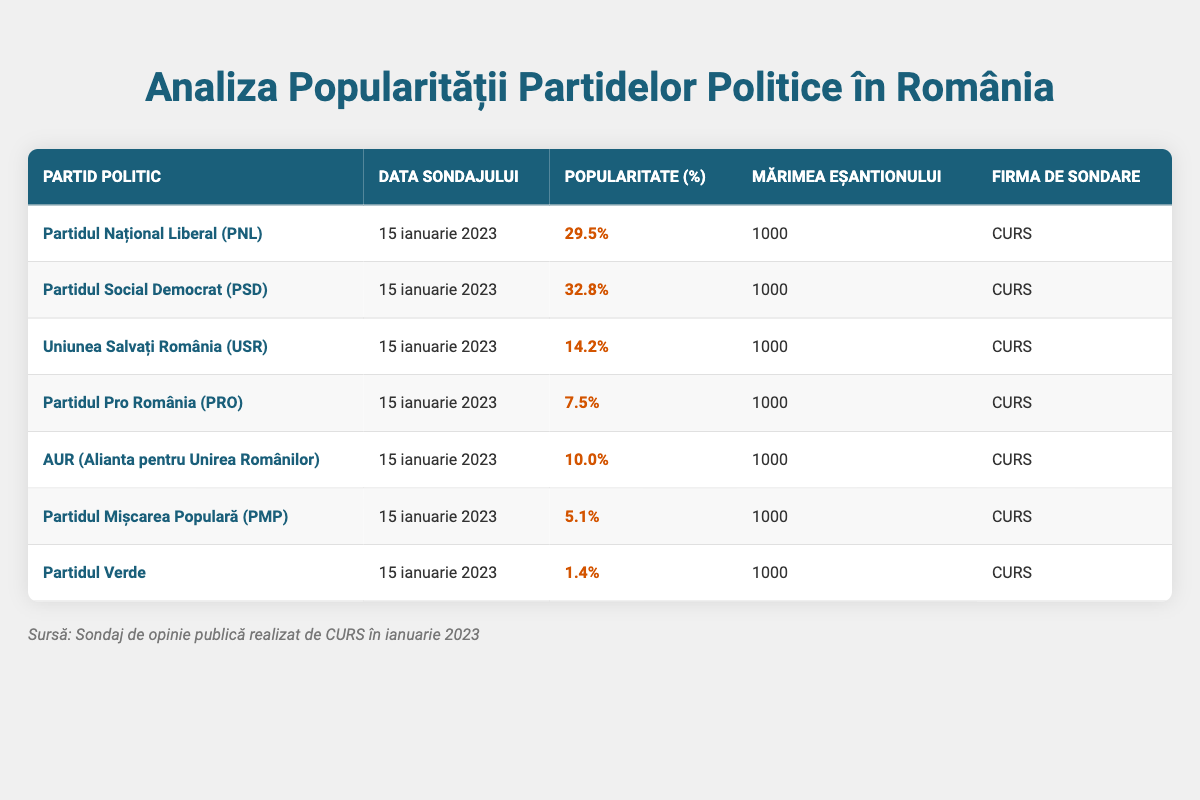What is the popularity percentage of Partidul Național Liberal (PNL)? The table shows that the popularity percentage of Partidul Național Liberal (PNL) is listed directly in the corresponding row under the "Popularitate (%)" column. According to the data, it is 29.5%.
Answer: 29.5% Which party has the highest popularity percentage? By reviewing the "Popularitate (%)" column, we see that Partidul Social Democrat (PSD) has the highest percentage at 32.8%. This value is greater than any other listed party in the table.
Answer: Partidul Social Democrat (PSD) How many parties have a popularity percentage below 10%? We need to look at the "Popularitate (%)" column and count how many entries are below 10%. Partidul Pro România (PRO) at 7.5%, AUR at 10.0%, Partidul Mișcarea Populară (PMP) at 5.1%, and Partidul Verde at 1.4% indicate that three parties (PRO, PMP, and Verde) have a popularity percentage below 10%.
Answer: 3 What is the average popularity percentage of all the political parties listed? To calculate the average, we sum the popularity percentages: 29.5 + 32.8 + 14.2 + 7.5 + 10.0 + 5.1 + 1.4 = 100.5. There are 7 parties, so the average is 100.5 / 7 = 14.36%.
Answer: 14.36% Is the sample size the same for all parties? Checking the "Mărimea Eșantionului" column, we observe that all entries show a sample size of 1000, confirming that the sample size is consistent for all parties in this survey.
Answer: Yes Which party has the lowest popularity percentage? Inspecting the "Popularitate (%)" column, we can see that Partidul Verde has the lowest percentage at 1.4%. This is visibly lower than all other values in the column.
Answer: Partidul Verde What percentage difference in popularity is there between Partidul Social Democrat (PSD) and Uniunea Salvați România (USR)? The difference is calculated by subtracting the popularity percentage of USR from PSD: 32.8% (PSD) - 14.2% (USR) = 18.6%. This shows how much more popular PSD is compared to USR.
Answer: 18.6% Are there any parties with a popularity percentage above 20%? By examining the "Popularitate (%)" column, we see that Partidul Național Liberal (PNL) at 29.5% and Partidul Social Democrat (PSD) at 32.8% are both above 20%. This indicates there are parties meeting that criterion.
Answer: Yes 